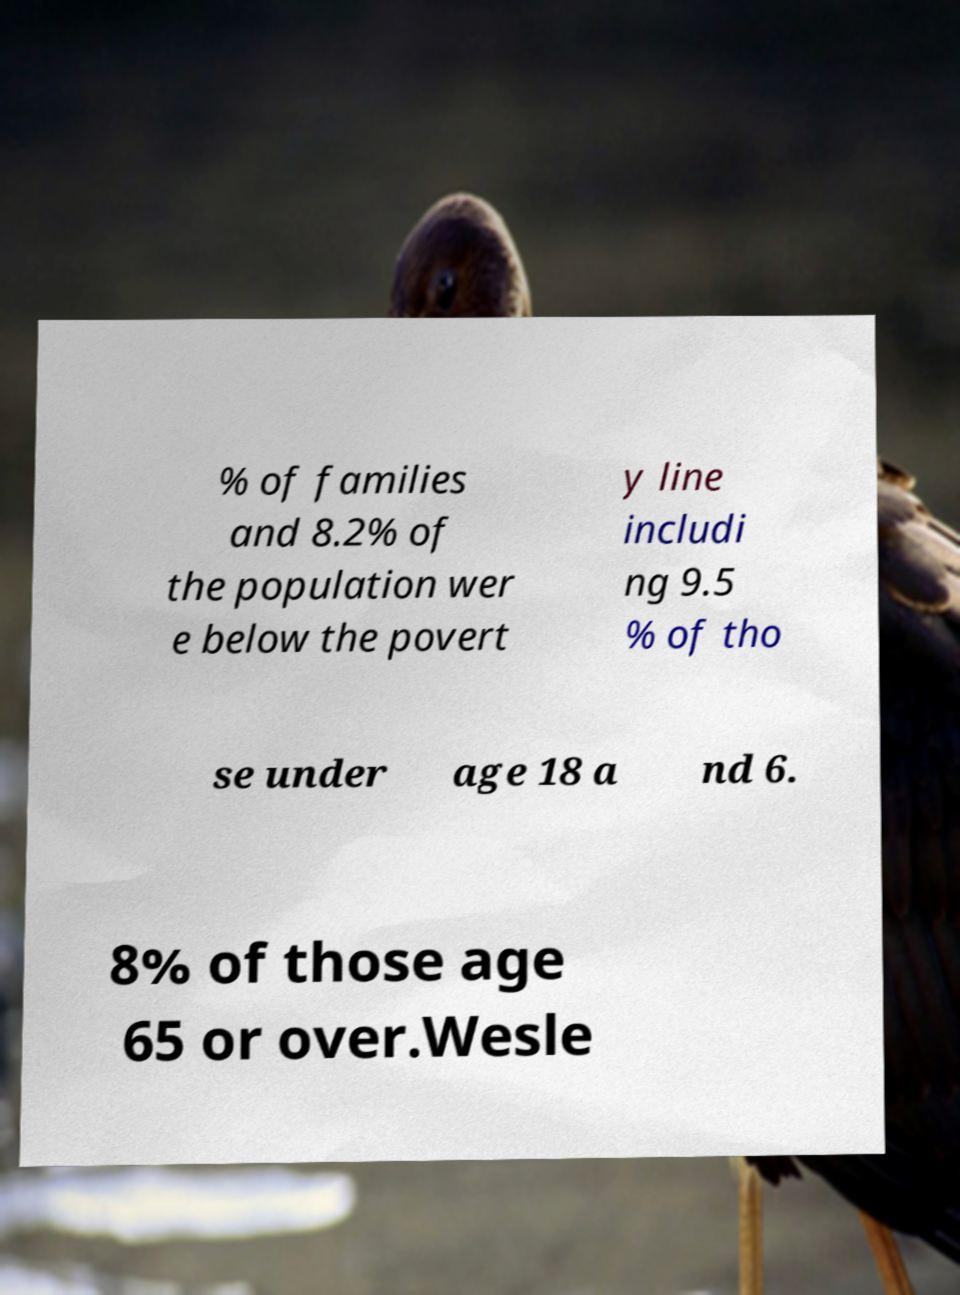Can you accurately transcribe the text from the provided image for me? % of families and 8.2% of the population wer e below the povert y line includi ng 9.5 % of tho se under age 18 a nd 6. 8% of those age 65 or over.Wesle 